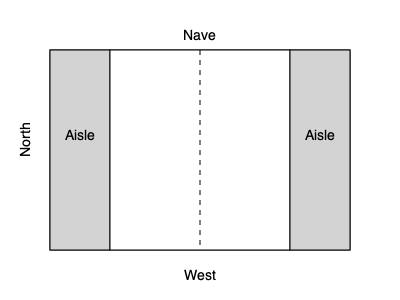As a pastor familiar with church architecture, analyze the floor plan shown above. What architectural style does this layout most likely represent, and what is the significance of the central area labeled "Nave" in Christian worship? To answer this question, let's analyze the floor plan step-by-step:

1. Layout: The plan shows a rectangular building divided into three longitudinal sections.

2. Central section: The largest central area is labeled "Nave," which is the main body of the church where the congregation gathers.

3. Side sections: There are two narrower side sections labeled "Aisle" on either side of the Nave.

4. Orientation: The plan is oriented with West at the bottom, following traditional church architecture where the main entrance is typically on the western end.

5. Architectural style: This layout is characteristic of the Basilica plan, which was common in early Christian and Romanesque architecture. The Basilica plan features a long central Nave flanked by side aisles.

6. Significance of the Nave:
   a) The Nave is the primary gathering space for worshippers.
   b) It provides a clear sightline to the altar, which would typically be located at the eastern end (top of the diagram).
   c) The longitudinal layout of the Nave symbolizes the journey of faith, with worshippers moving towards the altar.
   d) The central position of the Nave emphasizes community and shared worship experience.

7. Christian symbolism: The cross-like shape formed by the Nave and transepts (not shown in this plan but often present in larger churches) represents the crucifixion of Christ.

Given this analysis, the architectural style is most likely Basilican, and the Nave serves as the central gathering space for communal worship, symbolizing the journey of faith and the unity of the congregation.
Answer: Basilican style; central gathering space for communal worship 